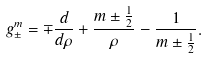Convert formula to latex. <formula><loc_0><loc_0><loc_500><loc_500>g _ { \pm } ^ { m } = \mp \frac { d } { d \rho } + \frac { m \pm \frac { 1 } { 2 } } { \rho } - \frac { 1 } { m \pm \frac { 1 } { 2 } } .</formula> 